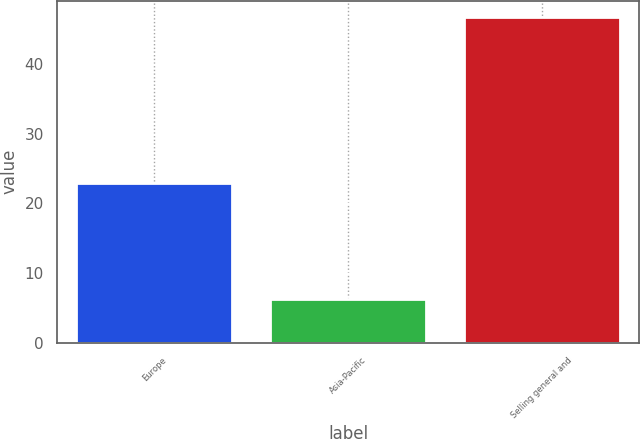Convert chart. <chart><loc_0><loc_0><loc_500><loc_500><bar_chart><fcel>Europe<fcel>Asia-Pacific<fcel>Selling general and<nl><fcel>23<fcel>6.2<fcel>46.8<nl></chart> 